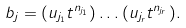Convert formula to latex. <formula><loc_0><loc_0><loc_500><loc_500>b _ { j } = ( u _ { j _ { 1 } } t ^ { n _ { j _ { 1 } } } ) \dots ( u _ { j _ { r } } t ^ { n _ { j _ { r } } } ) .</formula> 